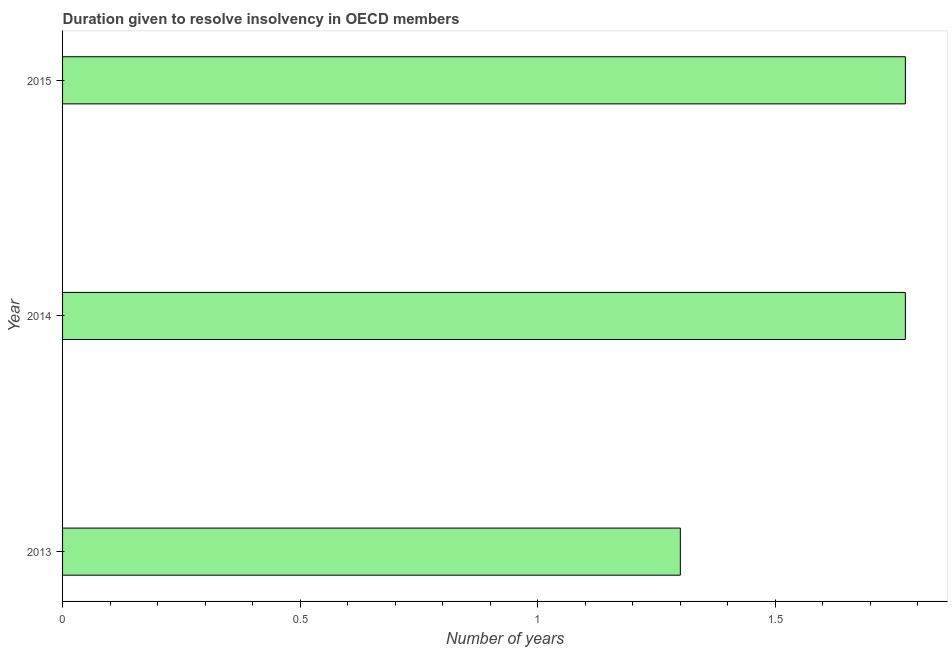Does the graph contain grids?
Your answer should be very brief. No. What is the title of the graph?
Offer a very short reply. Duration given to resolve insolvency in OECD members. What is the label or title of the X-axis?
Provide a short and direct response. Number of years. What is the label or title of the Y-axis?
Provide a short and direct response. Year. Across all years, what is the maximum number of years to resolve insolvency?
Your answer should be very brief. 1.77. Across all years, what is the minimum number of years to resolve insolvency?
Provide a succinct answer. 1.3. What is the sum of the number of years to resolve insolvency?
Provide a short and direct response. 4.85. What is the difference between the number of years to resolve insolvency in 2013 and 2014?
Provide a short and direct response. -0.47. What is the average number of years to resolve insolvency per year?
Provide a short and direct response. 1.62. What is the median number of years to resolve insolvency?
Ensure brevity in your answer.  1.77. In how many years, is the number of years to resolve insolvency greater than 0.9 ?
Your answer should be very brief. 3. What is the ratio of the number of years to resolve insolvency in 2014 to that in 2015?
Give a very brief answer. 1. Is the number of years to resolve insolvency in 2013 less than that in 2015?
Provide a short and direct response. Yes. What is the difference between the highest and the second highest number of years to resolve insolvency?
Your response must be concise. 0. What is the difference between the highest and the lowest number of years to resolve insolvency?
Provide a short and direct response. 0.47. In how many years, is the number of years to resolve insolvency greater than the average number of years to resolve insolvency taken over all years?
Ensure brevity in your answer.  2. How many years are there in the graph?
Provide a succinct answer. 3. What is the Number of years of 2014?
Your response must be concise. 1.77. What is the Number of years of 2015?
Provide a succinct answer. 1.77. What is the difference between the Number of years in 2013 and 2014?
Offer a terse response. -0.47. What is the difference between the Number of years in 2013 and 2015?
Your response must be concise. -0.47. What is the difference between the Number of years in 2014 and 2015?
Provide a short and direct response. 0. What is the ratio of the Number of years in 2013 to that in 2014?
Offer a very short reply. 0.73. What is the ratio of the Number of years in 2013 to that in 2015?
Offer a very short reply. 0.73. What is the ratio of the Number of years in 2014 to that in 2015?
Keep it short and to the point. 1. 